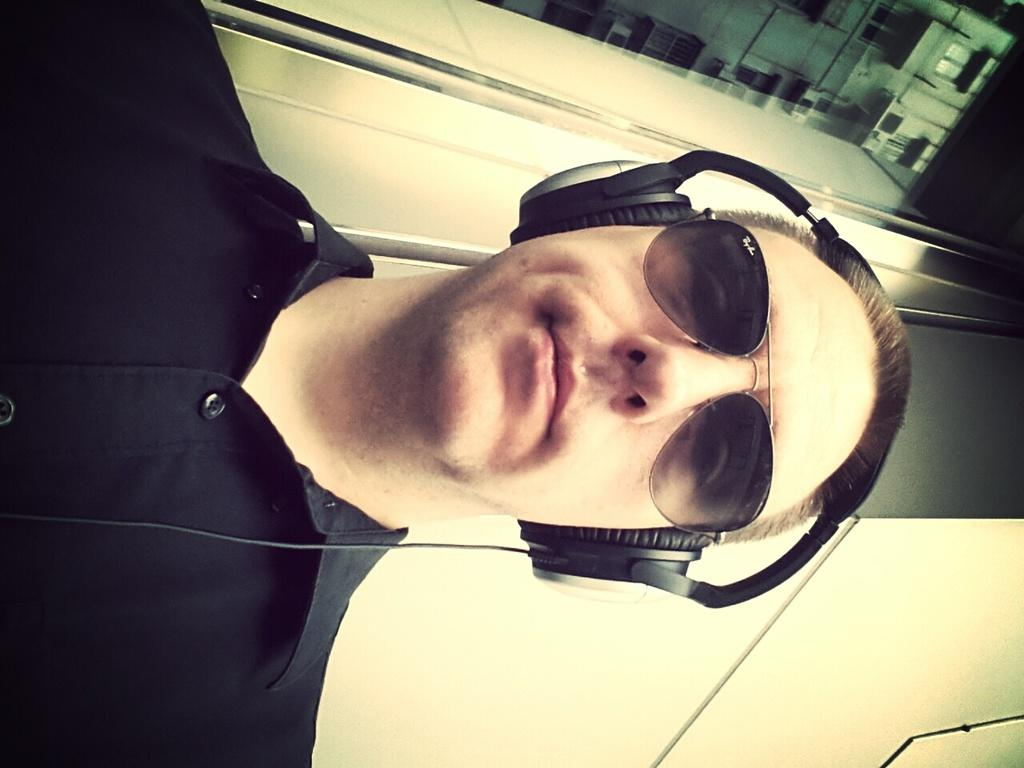Who is present in the image? There is a person in the image. What accessories is the person wearing? The person is wearing headphones and spectacles. What can be seen in the background of the image? There is a wall and a building in the image. What type of cow can be seen grazing near the building in the image? There is no cow present in the image; it only features a person wearing headphones and spectacles, with a wall and a building in the background. 